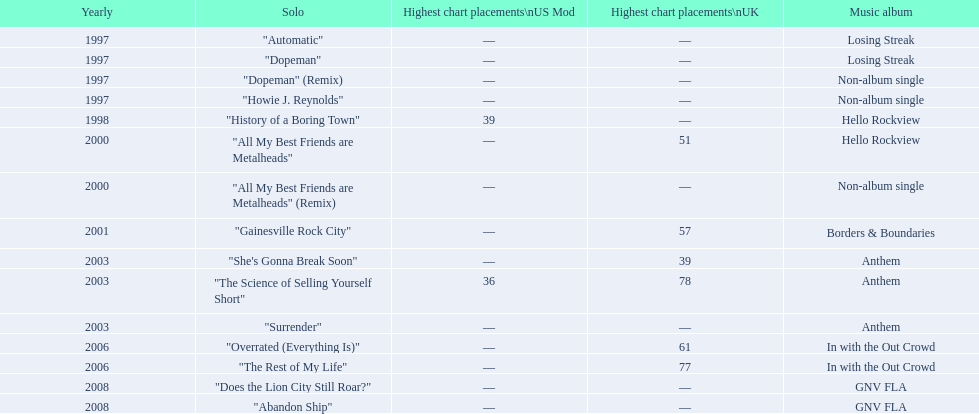Name one other single that was on the losing streak album besides "dopeman". "Automatic". 